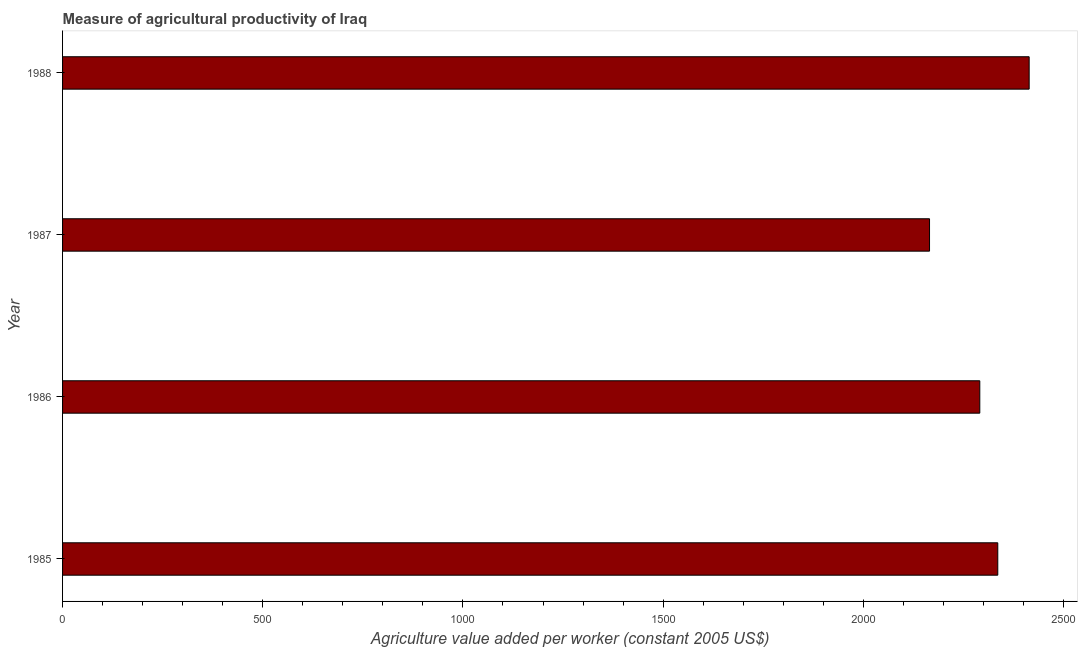Does the graph contain any zero values?
Make the answer very short. No. Does the graph contain grids?
Make the answer very short. No. What is the title of the graph?
Give a very brief answer. Measure of agricultural productivity of Iraq. What is the label or title of the X-axis?
Make the answer very short. Agriculture value added per worker (constant 2005 US$). What is the label or title of the Y-axis?
Ensure brevity in your answer.  Year. What is the agriculture value added per worker in 1985?
Provide a short and direct response. 2335.87. Across all years, what is the maximum agriculture value added per worker?
Make the answer very short. 2414.23. Across all years, what is the minimum agriculture value added per worker?
Offer a very short reply. 2165.4. In which year was the agriculture value added per worker maximum?
Your response must be concise. 1988. In which year was the agriculture value added per worker minimum?
Provide a succinct answer. 1987. What is the sum of the agriculture value added per worker?
Ensure brevity in your answer.  9206.45. What is the difference between the agriculture value added per worker in 1986 and 1988?
Provide a short and direct response. -123.29. What is the average agriculture value added per worker per year?
Your response must be concise. 2301.61. What is the median agriculture value added per worker?
Give a very brief answer. 2313.41. In how many years, is the agriculture value added per worker greater than 500 US$?
Provide a succinct answer. 4. What is the ratio of the agriculture value added per worker in 1985 to that in 1987?
Make the answer very short. 1.08. Is the agriculture value added per worker in 1986 less than that in 1987?
Give a very brief answer. No. What is the difference between the highest and the second highest agriculture value added per worker?
Keep it short and to the point. 78.36. Is the sum of the agriculture value added per worker in 1987 and 1988 greater than the maximum agriculture value added per worker across all years?
Your response must be concise. Yes. What is the difference between the highest and the lowest agriculture value added per worker?
Offer a very short reply. 248.83. In how many years, is the agriculture value added per worker greater than the average agriculture value added per worker taken over all years?
Provide a succinct answer. 2. How many bars are there?
Offer a very short reply. 4. How many years are there in the graph?
Offer a very short reply. 4. What is the difference between two consecutive major ticks on the X-axis?
Your answer should be very brief. 500. Are the values on the major ticks of X-axis written in scientific E-notation?
Provide a succinct answer. No. What is the Agriculture value added per worker (constant 2005 US$) of 1985?
Your response must be concise. 2335.87. What is the Agriculture value added per worker (constant 2005 US$) of 1986?
Provide a short and direct response. 2290.94. What is the Agriculture value added per worker (constant 2005 US$) in 1987?
Give a very brief answer. 2165.4. What is the Agriculture value added per worker (constant 2005 US$) in 1988?
Offer a very short reply. 2414.23. What is the difference between the Agriculture value added per worker (constant 2005 US$) in 1985 and 1986?
Your answer should be compact. 44.93. What is the difference between the Agriculture value added per worker (constant 2005 US$) in 1985 and 1987?
Make the answer very short. 170.46. What is the difference between the Agriculture value added per worker (constant 2005 US$) in 1985 and 1988?
Keep it short and to the point. -78.36. What is the difference between the Agriculture value added per worker (constant 2005 US$) in 1986 and 1987?
Give a very brief answer. 125.54. What is the difference between the Agriculture value added per worker (constant 2005 US$) in 1986 and 1988?
Keep it short and to the point. -123.29. What is the difference between the Agriculture value added per worker (constant 2005 US$) in 1987 and 1988?
Give a very brief answer. -248.83. What is the ratio of the Agriculture value added per worker (constant 2005 US$) in 1985 to that in 1987?
Provide a short and direct response. 1.08. What is the ratio of the Agriculture value added per worker (constant 2005 US$) in 1986 to that in 1987?
Your answer should be compact. 1.06. What is the ratio of the Agriculture value added per worker (constant 2005 US$) in 1986 to that in 1988?
Offer a terse response. 0.95. What is the ratio of the Agriculture value added per worker (constant 2005 US$) in 1987 to that in 1988?
Your response must be concise. 0.9. 